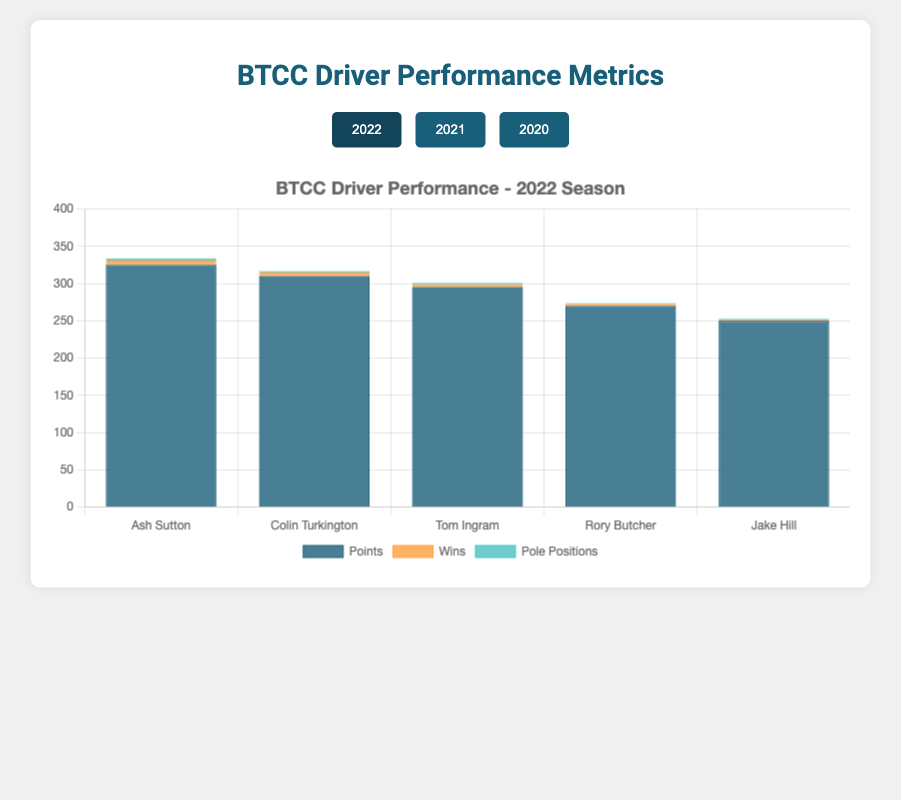Which driver had the highest points in the 2021 season? By looking at the tallest section of the stacked bar labeled "Points" for the 2021 season, Ash Sutton had the highest points.
Answer: Ash Sutton How many wins did Tom Ingram have in the 2022 season, and how does that compare to his wins in the 2021 season? By looking at the "Wins" section of Tom Ingram's bar for both 2021 and 2022, he had 4 wins in 2022 and 5 wins in 2021. Therefore, he had 1 fewer win in 2022.
Answer: 1 fewer win Which driver improved their pole positions from the 2020 to the 2021 season? By comparing the "Pole Positions" sections of bars for 2020 and 2021, Jake Hill had 1 pole position in 2020 and 2 in 2021. No other drivers increased their pole positions.
Answer: Jake Hill What is the total number of victories (wins) for Ash Sutton across all three seasons? By summing the "Wins" sections of Ash Sutton's bars for 2020 (7), 2021 (8), and 2022 (6), the total number of victories is 7 + 8 + 6 = 21.
Answer: 21 Which season did Colin Turkington achieve the highest combined total of points, wins, and pole positions? By summing the values from the sections labeled "Points," "Wins," and "Pole Positions" for each season: 
2022: 310 + 5 + 2 = 317
2021: 335 + 6 + 3 = 344
2020: 330 + 6 + 2 = 338
The highest total is 344 in 2021.
Answer: 2021 Compare the performance improvements or declines in terms of points for Jake Hill from the 2020 to the 2022 season. By looking at the "Points" sections for Jake Hill in 2020 (265) and 2022 (250), there is a decline of 265 - 250 = 15 points.
Answer: Decline of 15 points Who had the least number of wins in the 2022 season, and how many wins did they have? By looking at the smallest section of the "Wins" category in the 2022 season, Jake Hill had the least number of wins with 2.
Answer: Jake Hill, 2 wins How does Ash Sutton's total number of pole positions in 2020 and 2021 compare with his number in 2022? By summing the "Pole Positions" for Ash Sutton in 2020 (3) and 2021 (4), which totals to 7, and comparing with 2022 (3), the number in 2022 is less than the combined previous two years.
Answer: Less, 3 in 2022 Overall, did Tom Ingram's total points increase or decrease from 2020 to 2022? By comparing Tom Ingram's "Points" in 2020 (290) and 2022 (295), his total points increased by 5 points.
Answer: Increased 